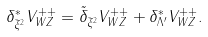Convert formula to latex. <formula><loc_0><loc_0><loc_500><loc_500>\delta ^ { * } _ { \bar { \xi } ^ { 2 } } V ^ { + + } _ { W Z } = \tilde { \delta } _ { \bar { \xi } ^ { 2 } } V ^ { + + } _ { W Z } + \delta ^ { * } _ { \Lambda ^ { \prime } } V ^ { + + } _ { W Z } .</formula> 